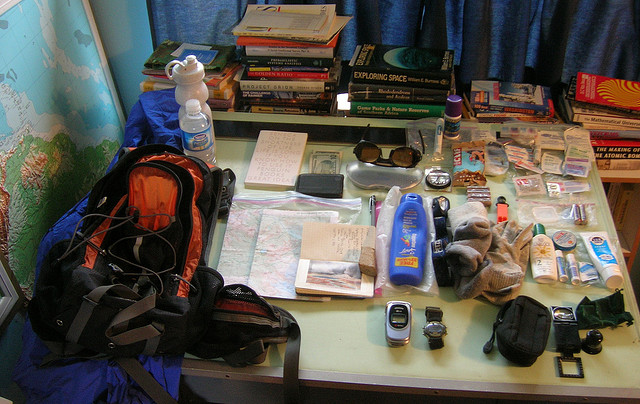Can you list the electronic items you see? Certainly! The electronic items include a mobile phone, a camera with a lens, possibly a charger or power supply, and what appears to be a GPS device. 